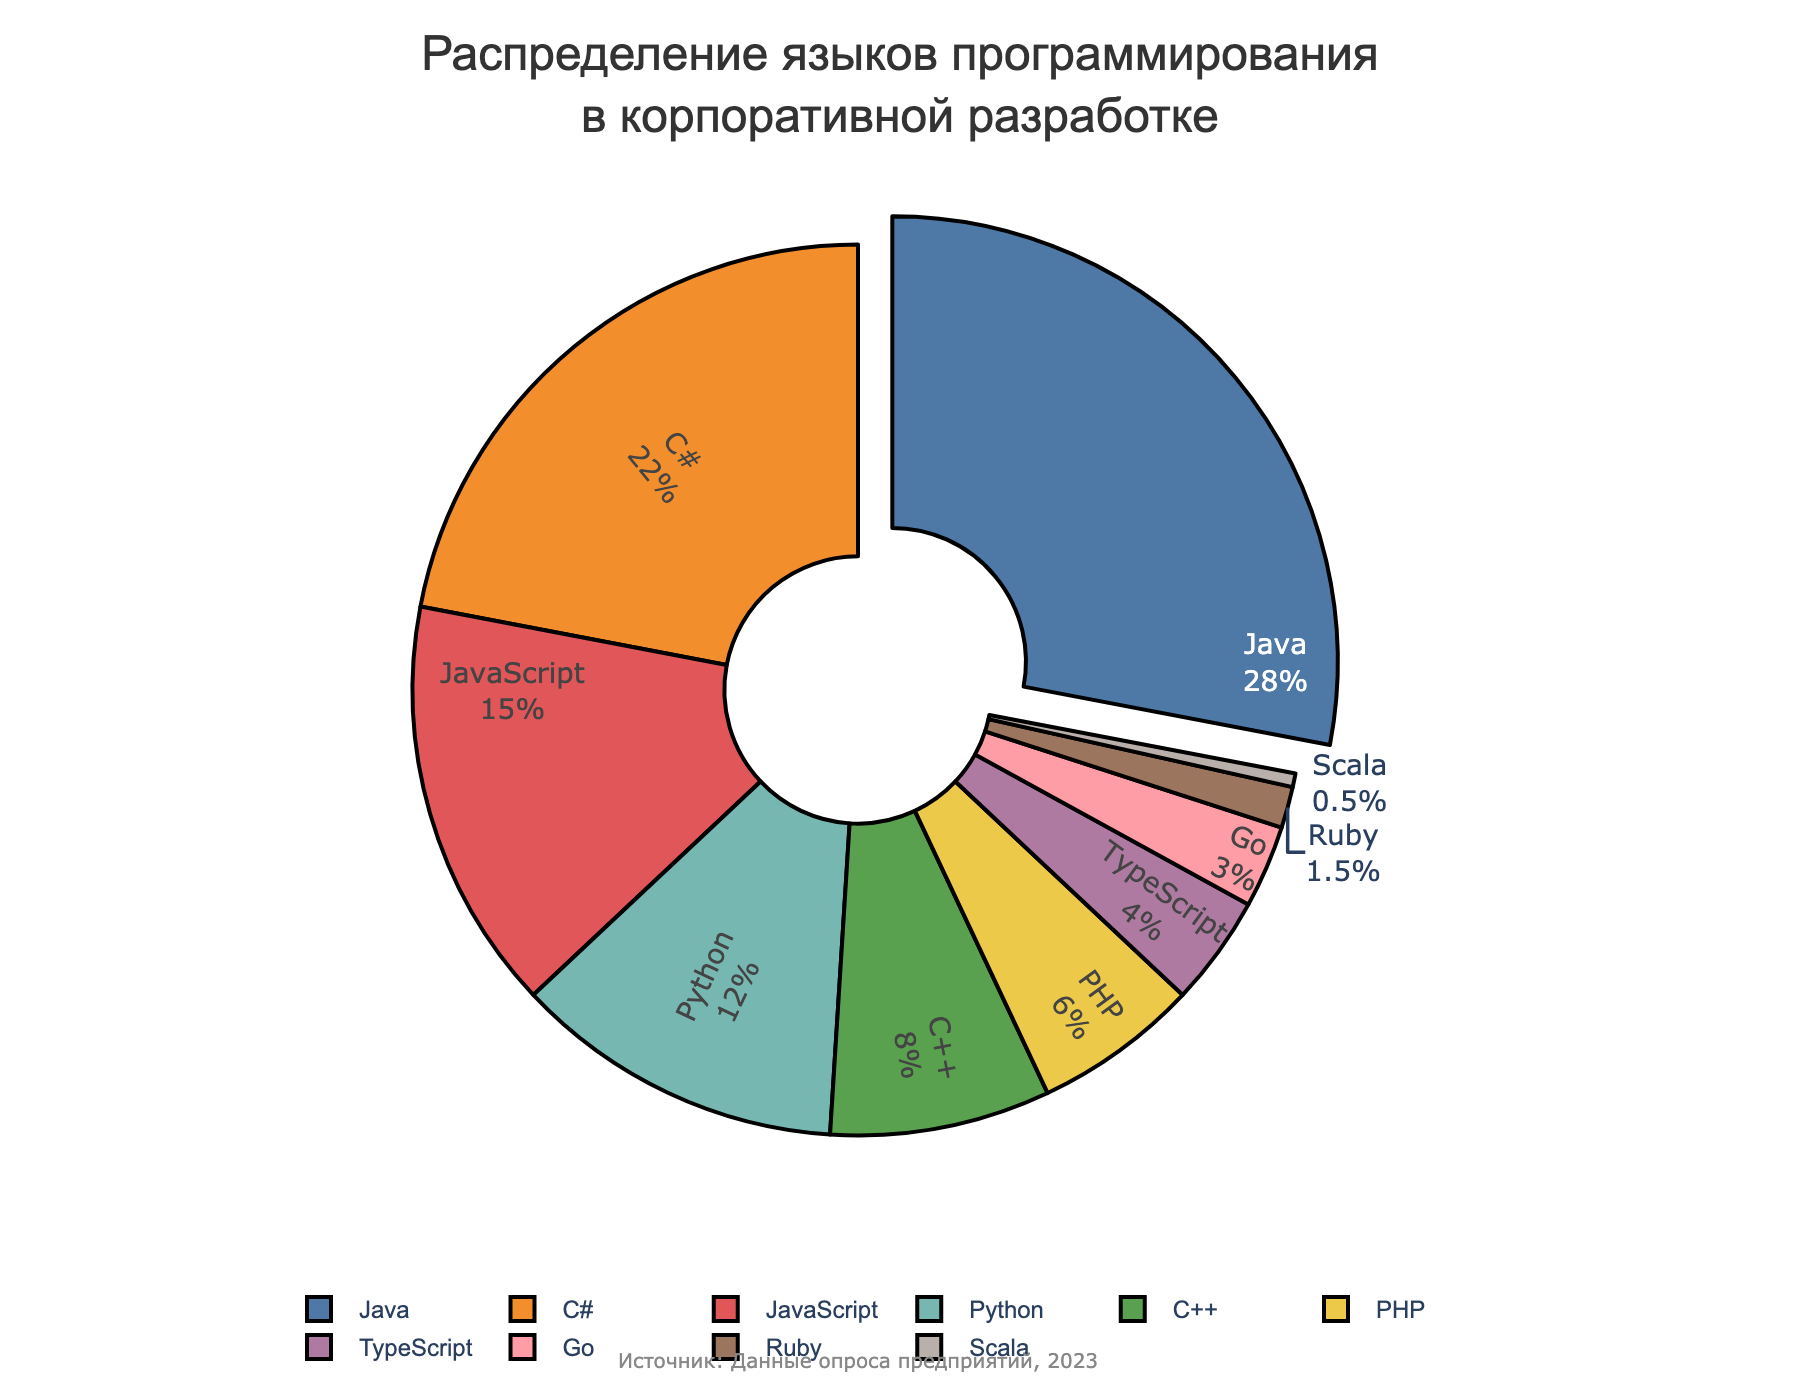Which programming language has the largest share? The figure shows the distribution of programming languages, and Java has the largest share, which is visually pulled out from the pie chart. Hence, Java leads with the highest percentage.
Answer: Java What percentage of languages used consists of C# and C++ combined? From the data, C# has 22% and C++ has 8%. Adding these together: 22% + 8% = 30%.
Answer: 30% How does the usage of Python compare to PHP? The chart shows that Python has 12% and PHP has 6%. Comparing these values, Python is used exactly twice as much as PHP.
Answer: Python is twice as much as PHP Which two languages combined make up more than a quarter of all used languages? Java has 28% while JavaScript has 15%. Adding them together results in 28% + 15% = 43%, which is more than 25%. Hence, Java and JavaScript combined make up more than a quarter.
Answer: Java and JavaScript What is the total percentage of the least used languages (Go, Ruby, and Scala)? From the data: Go has 3%, Ruby has 1.5%, and Scala has 0.5%. Summing these up: 3% + 1.5% + 0.5% = 5%.
Answer: 5% Which language is used more, TypeScript or PHP? The figure shows TypeScript at 4% and PHP at 6%. Hence, PHP is used more than TypeScript.
Answer: PHP What fraction of the languages have a usage percentage greater than 10%? From the chart: Java (28%), C# (22%), JavaScript (15%), and Python (12%) have percentages greater than 10%. The total number of languages listed is 10. Hence, 4/10 = 0.4 or 40%.
Answer: 40% If you combine the usage of JavaScript, TypeScript, and PHP, what is their total percentage share? JavaScript has 15%, TypeScript has 4%, and PHP has 6%. Adding these together: 15% + 4% + 6% = 25%.
Answer: 25% What is the difference in percentage usage between the most popular and the least popular language? Java is the most popular with 28%, and Scala is the least popular with 0.5%. The difference is 28% - 0.5% = 27.5%.
Answer: 27.5% What percentage of languages used is made up by the top three languages? The top three languages by percentage are Java (28%), C# (22%), and JavaScript (15%). Summing these up: 28% + 22% + 15% = 65%.
Answer: 65% 